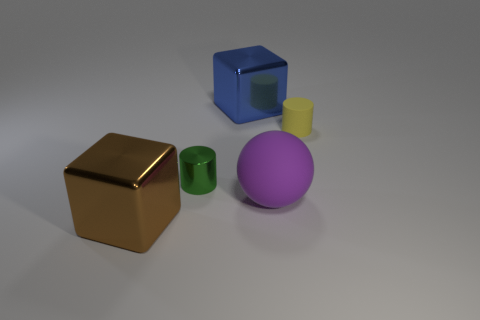Add 3 large blue shiny blocks. How many objects exist? 8 Subtract all balls. How many objects are left? 4 Add 2 large brown shiny cubes. How many large brown shiny cubes exist? 3 Subtract 0 purple cylinders. How many objects are left? 5 Subtract all large purple matte cylinders. Subtract all large blue metallic objects. How many objects are left? 4 Add 4 big blue metal blocks. How many big blue metal blocks are left? 5 